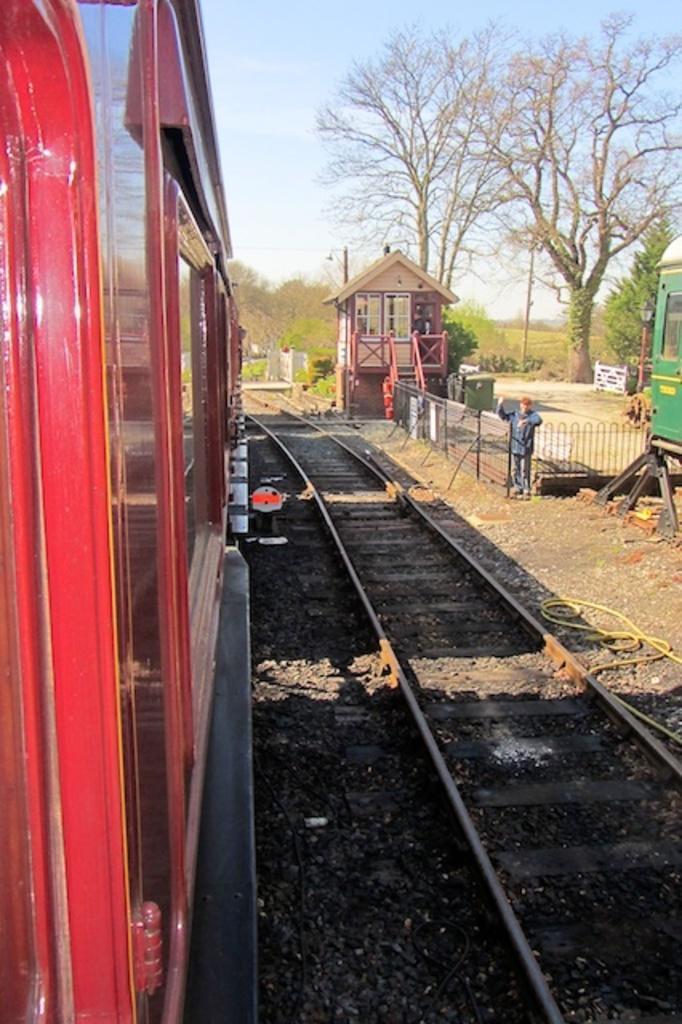Please provide a concise description of this image. On the left side of the image we can see a train and railway track. Here we can see a person, fence, shed, and trees. On the right side of the image we can see a train which is truncated. In the background there is sky. 